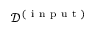Convert formula to latex. <formula><loc_0><loc_0><loc_500><loc_500>\mathcal { D } ^ { ( i n p u t ) }</formula> 